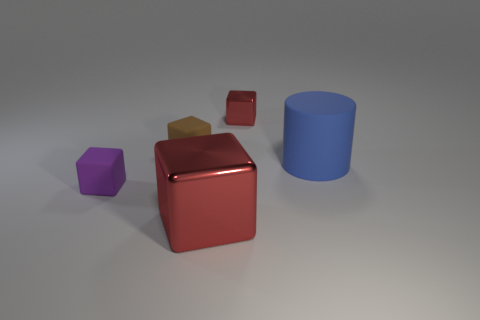There is a brown matte thing; does it have the same size as the metal block behind the purple thing?
Give a very brief answer. Yes. What number of shiny things are large objects or cubes?
Provide a succinct answer. 2. Is the color of the small metal object the same as the metal cube in front of the tiny metal cube?
Offer a terse response. Yes. What is the shape of the small brown matte object?
Offer a very short reply. Cube. How big is the red object in front of the matte thing to the right of the large thing in front of the large blue cylinder?
Offer a very short reply. Large. What number of other things are there of the same shape as the small metal object?
Your response must be concise. 3. Does the red metallic object that is behind the large blue matte cylinder have the same shape as the purple object left of the big block?
Give a very brief answer. Yes. What number of cylinders are either big purple rubber things or small red metallic objects?
Provide a short and direct response. 0. There is a red block that is in front of the cube behind the matte thing that is behind the big rubber thing; what is its material?
Give a very brief answer. Metal. What number of other objects are the same size as the blue rubber object?
Make the answer very short. 1. 